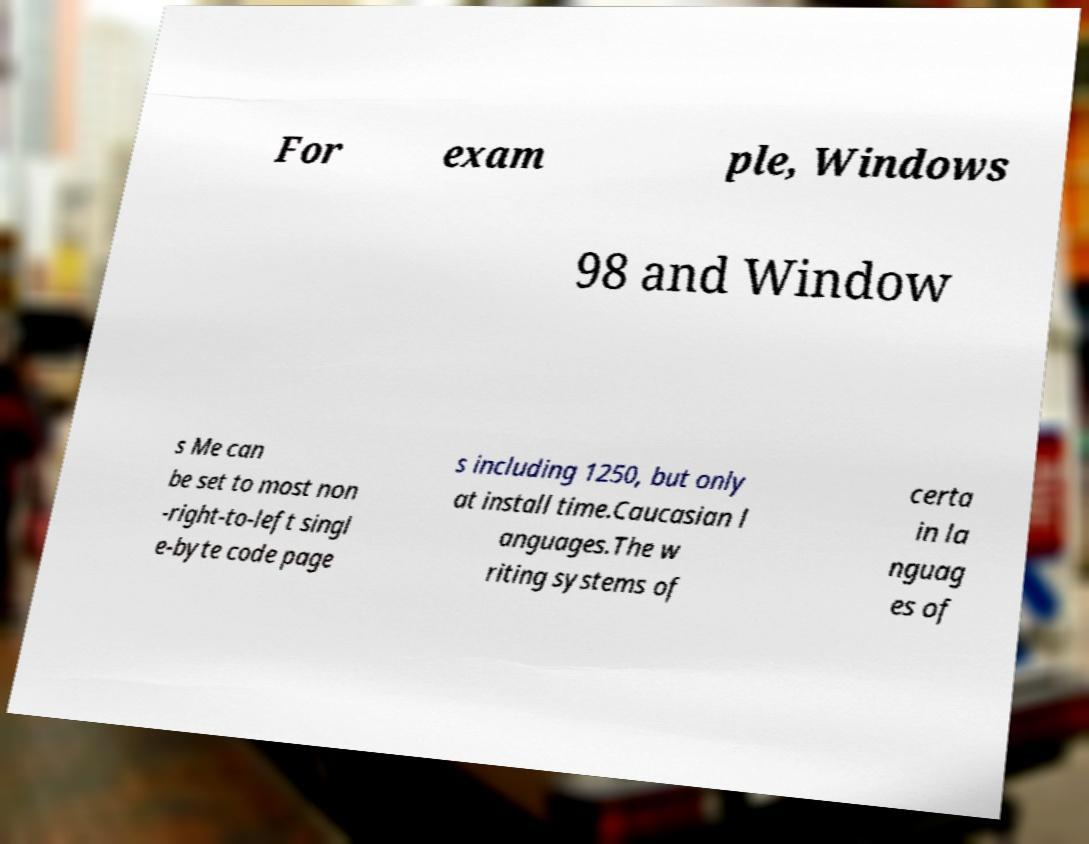Please identify and transcribe the text found in this image. For exam ple, Windows 98 and Window s Me can be set to most non -right-to-left singl e-byte code page s including 1250, but only at install time.Caucasian l anguages.The w riting systems of certa in la nguag es of 